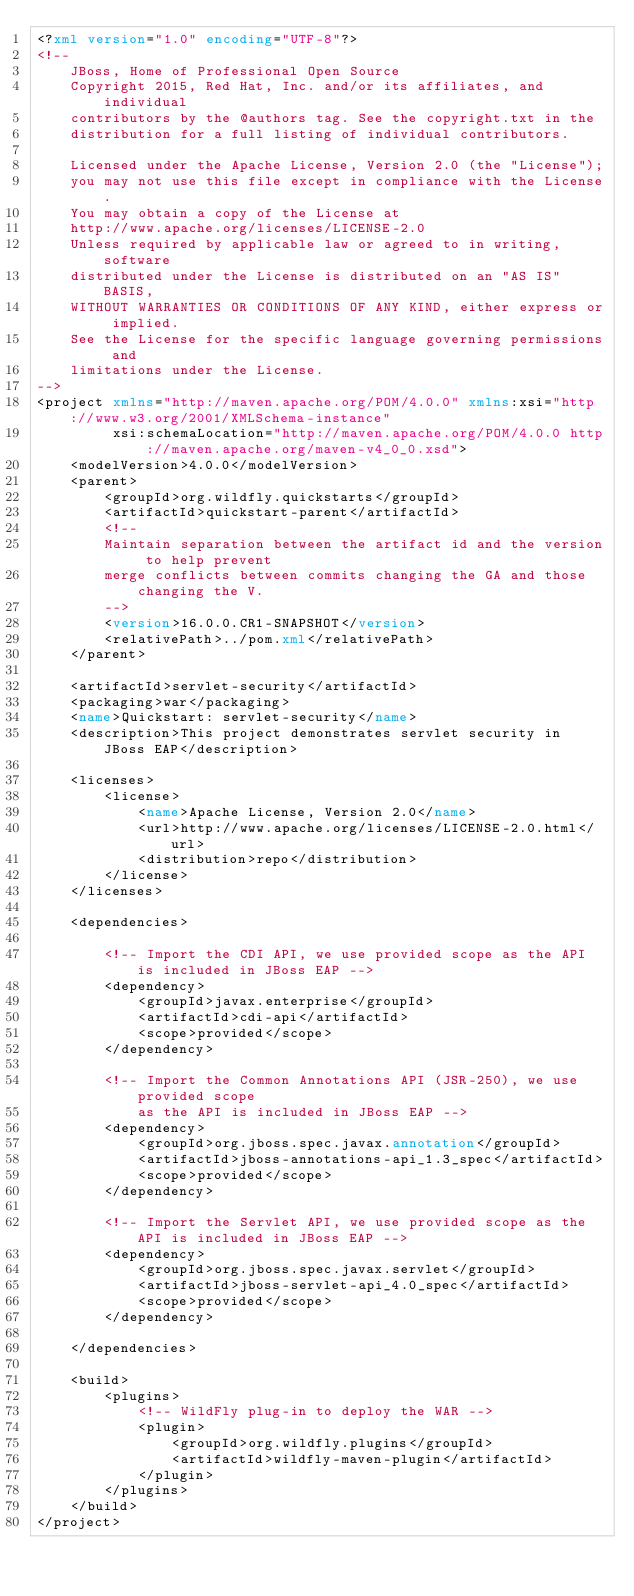Convert code to text. <code><loc_0><loc_0><loc_500><loc_500><_XML_><?xml version="1.0" encoding="UTF-8"?>
<!--
    JBoss, Home of Professional Open Source
    Copyright 2015, Red Hat, Inc. and/or its affiliates, and individual
    contributors by the @authors tag. See the copyright.txt in the
    distribution for a full listing of individual contributors.

    Licensed under the Apache License, Version 2.0 (the "License");
    you may not use this file except in compliance with the License.
    You may obtain a copy of the License at
    http://www.apache.org/licenses/LICENSE-2.0
    Unless required by applicable law or agreed to in writing, software
    distributed under the License is distributed on an "AS IS" BASIS,
    WITHOUT WARRANTIES OR CONDITIONS OF ANY KIND, either express or implied.
    See the License for the specific language governing permissions and
    limitations under the License.
-->
<project xmlns="http://maven.apache.org/POM/4.0.0" xmlns:xsi="http://www.w3.org/2001/XMLSchema-instance"
         xsi:schemaLocation="http://maven.apache.org/POM/4.0.0 http://maven.apache.org/maven-v4_0_0.xsd">
    <modelVersion>4.0.0</modelVersion>
    <parent>
        <groupId>org.wildfly.quickstarts</groupId>
        <artifactId>quickstart-parent</artifactId>
        <!--
        Maintain separation between the artifact id and the version to help prevent
        merge conflicts between commits changing the GA and those changing the V.
        -->
        <version>16.0.0.CR1-SNAPSHOT</version>
        <relativePath>../pom.xml</relativePath>
    </parent>

    <artifactId>servlet-security</artifactId>
    <packaging>war</packaging>
    <name>Quickstart: servlet-security</name>
    <description>This project demonstrates servlet security in JBoss EAP</description>

    <licenses>
        <license>
            <name>Apache License, Version 2.0</name>
            <url>http://www.apache.org/licenses/LICENSE-2.0.html</url>
            <distribution>repo</distribution>
        </license>
    </licenses>

    <dependencies>

        <!-- Import the CDI API, we use provided scope as the API is included in JBoss EAP -->
        <dependency>
            <groupId>javax.enterprise</groupId>
            <artifactId>cdi-api</artifactId>
            <scope>provided</scope>
        </dependency>

        <!-- Import the Common Annotations API (JSR-250), we use provided scope
            as the API is included in JBoss EAP -->
        <dependency>
            <groupId>org.jboss.spec.javax.annotation</groupId>
            <artifactId>jboss-annotations-api_1.3_spec</artifactId>
            <scope>provided</scope>
        </dependency>

        <!-- Import the Servlet API, we use provided scope as the API is included in JBoss EAP -->
        <dependency>
            <groupId>org.jboss.spec.javax.servlet</groupId>
            <artifactId>jboss-servlet-api_4.0_spec</artifactId>
            <scope>provided</scope>
        </dependency>

    </dependencies>

    <build>
        <plugins>
            <!-- WildFly plug-in to deploy the WAR -->
            <plugin>
                <groupId>org.wildfly.plugins</groupId>
                <artifactId>wildfly-maven-plugin</artifactId>
            </plugin>
        </plugins>
    </build>
</project>
</code> 